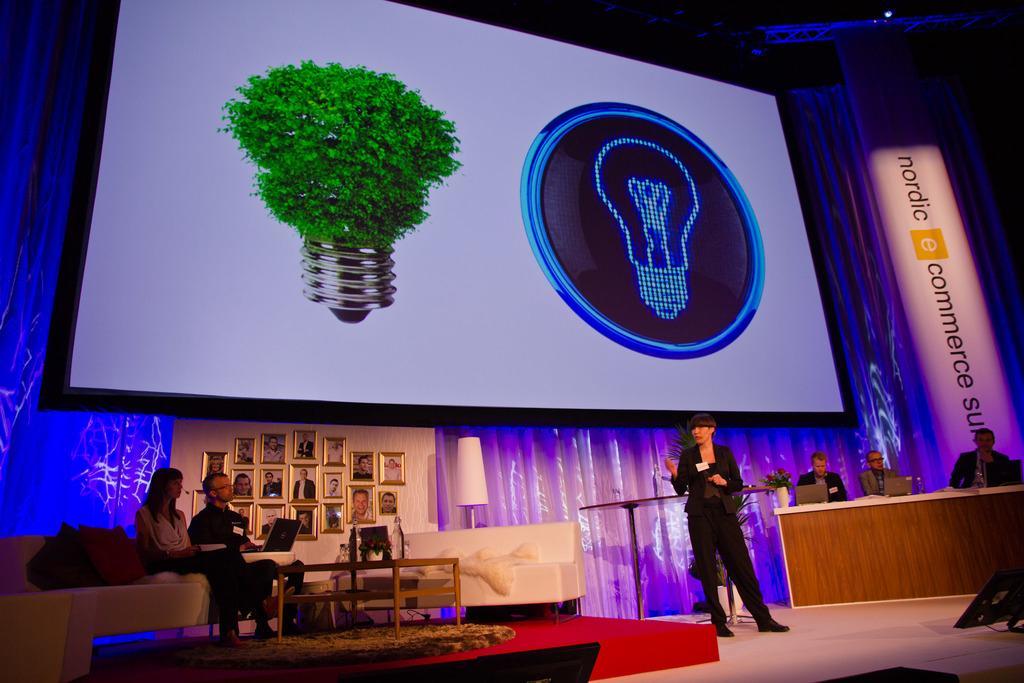Could you give a brief overview of what you see in this image? As we can see in the image there is a cloth, banner, photo frames, a lamp, table, few people sitting on sofa and there is a person standing over here and on table there are laptops. 